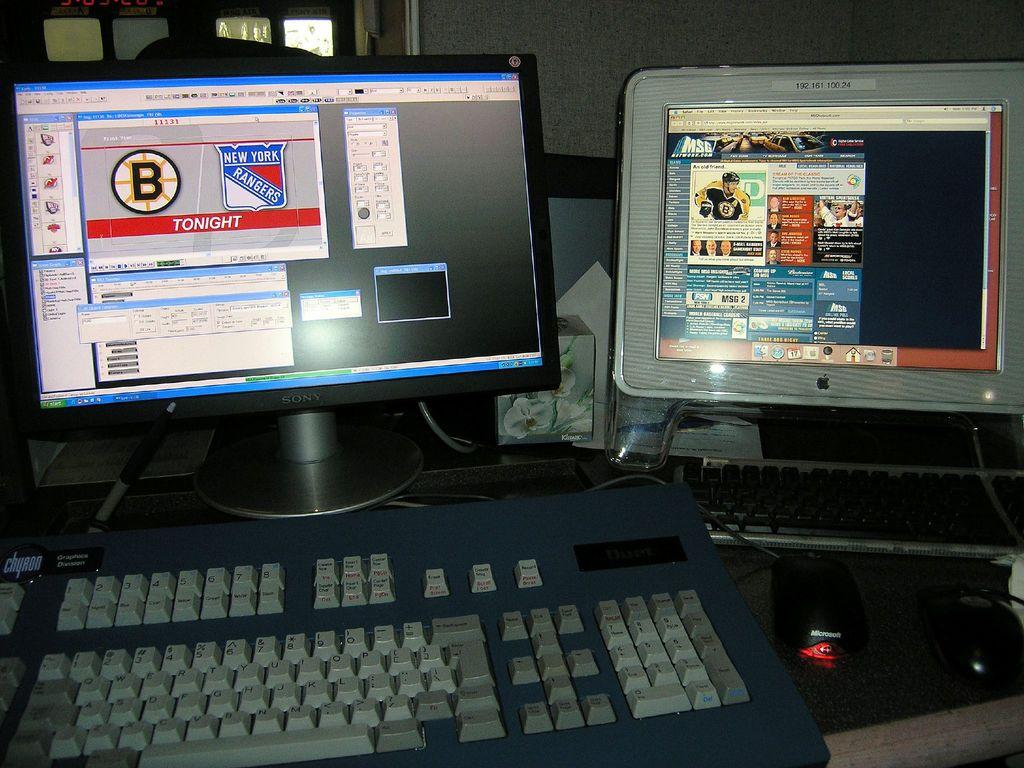<image>
Describe the image concisely. The screen on the left indicates that the New York Rangers are playing tonight. 